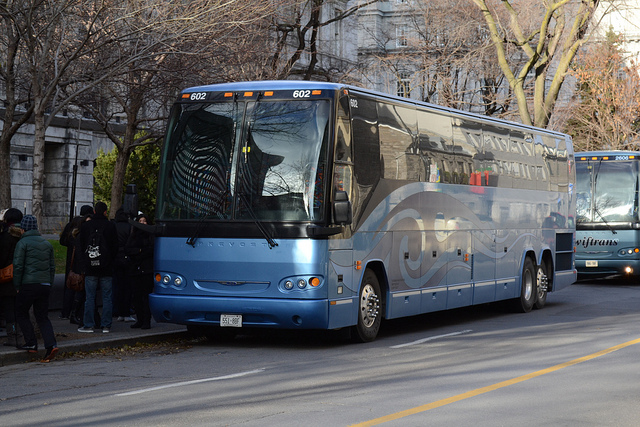Can you describe the surroundings of the bus? The bus is pictured in an urban environment, likely along a city street. There are leafless trees indicating it might be autumn or winter, and pedestrians appear to be waiting or boarding the bus, suggesting a pickup or drop-off location. Does the bus seem to be in motion or stationary? Given the presence of waiting or boarding passengers and the absence of motion blur in the image, it's likely that the bus is stationary at the moment the photo was taken. 